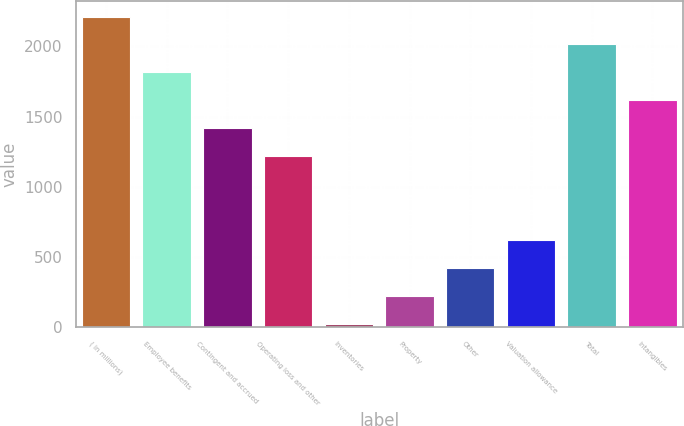Convert chart to OTSL. <chart><loc_0><loc_0><loc_500><loc_500><bar_chart><fcel>( in millions)<fcel>Employee benefits<fcel>Contingent and accrued<fcel>Operating loss and other<fcel>Inventories<fcel>Property<fcel>Other<fcel>Valuation allowance<fcel>Total<fcel>Intangibles<nl><fcel>2213<fcel>1815<fcel>1417<fcel>1218<fcel>24<fcel>223<fcel>422<fcel>621<fcel>2014<fcel>1616<nl></chart> 